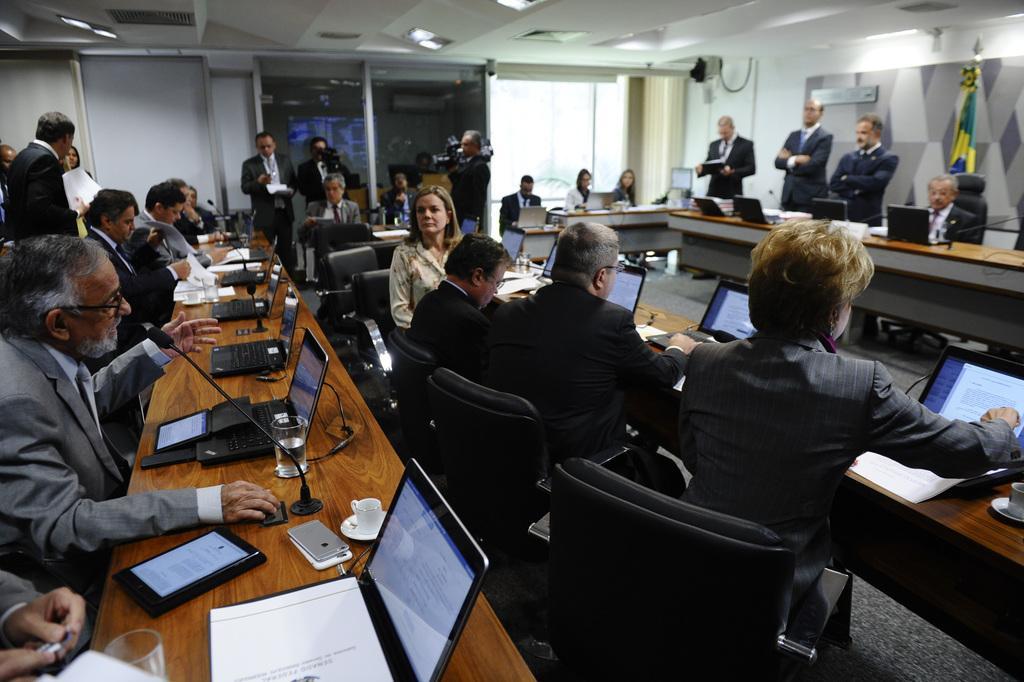Can you describe this image briefly? In this image I can see number of people where few of them are standing and rest all are sitting on chairs. I can also see a flag and few tables. On these tables I can see laptops, cell phones, cup, glass, mics and few papers. 